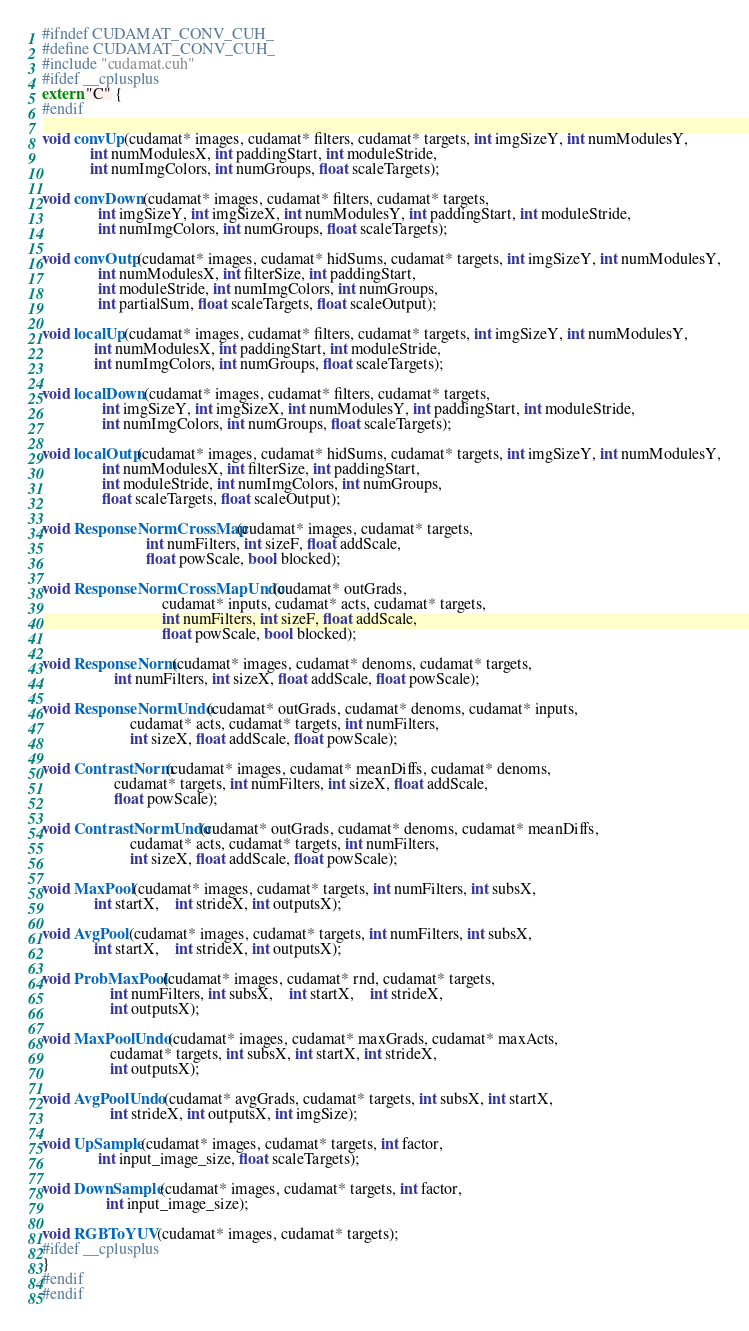Convert code to text. <code><loc_0><loc_0><loc_500><loc_500><_Cuda_>#ifndef CUDAMAT_CONV_CUH_
#define CUDAMAT_CONV_CUH_
#include "cudamat.cuh"
#ifdef __cplusplus
extern "C" {
#endif

void convUp(cudamat* images, cudamat* filters, cudamat* targets, int imgSizeY, int numModulesY,
            int numModulesX, int paddingStart, int moduleStride,
            int numImgColors, int numGroups, float scaleTargets);

void convDown(cudamat* images, cudamat* filters, cudamat* targets,
              int imgSizeY, int imgSizeX, int numModulesY, int paddingStart, int moduleStride,
              int numImgColors, int numGroups, float scaleTargets);

void convOutp(cudamat* images, cudamat* hidSums, cudamat* targets, int imgSizeY, int numModulesY,
              int numModulesX, int filterSize, int paddingStart,
              int moduleStride, int numImgColors, int numGroups,
              int partialSum, float scaleTargets, float scaleOutput);

void localUp(cudamat* images, cudamat* filters, cudamat* targets, int imgSizeY, int numModulesY,
             int numModulesX, int paddingStart, int moduleStride,
             int numImgColors, int numGroups, float scaleTargets);

void localDown(cudamat* images, cudamat* filters, cudamat* targets,
               int imgSizeY, int imgSizeX, int numModulesY, int paddingStart, int moduleStride,
               int numImgColors, int numGroups, float scaleTargets);

void localOutp(cudamat* images, cudamat* hidSums, cudamat* targets, int imgSizeY, int numModulesY,
               int numModulesX, int filterSize, int paddingStart,
               int moduleStride, int numImgColors, int numGroups,
               float scaleTargets, float scaleOutput);

void ResponseNormCrossMap(cudamat* images, cudamat* targets,
                          int numFilters, int sizeF, float addScale,
                          float powScale, bool blocked);

void ResponseNormCrossMapUndo(cudamat* outGrads,
                              cudamat* inputs, cudamat* acts, cudamat* targets,
                              int numFilters, int sizeF, float addScale,
                              float powScale, bool blocked);

void ResponseNorm(cudamat* images, cudamat* denoms, cudamat* targets,
                  int numFilters, int sizeX, float addScale, float powScale);

void ResponseNormUndo(cudamat* outGrads, cudamat* denoms, cudamat* inputs,
                      cudamat* acts, cudamat* targets, int numFilters,
                      int sizeX, float addScale, float powScale);

void ContrastNorm(cudamat* images, cudamat* meanDiffs, cudamat* denoms,
                  cudamat* targets, int numFilters, int sizeX, float addScale,
                  float powScale);

void ContrastNormUndo(cudamat* outGrads, cudamat* denoms, cudamat* meanDiffs,
                      cudamat* acts, cudamat* targets, int numFilters,
                      int sizeX, float addScale, float powScale);

void MaxPool(cudamat* images, cudamat* targets, int numFilters, int subsX,
             int startX,	int strideX, int outputsX);

void AvgPool(cudamat* images, cudamat* targets, int numFilters, int subsX,
             int startX,	int strideX, int outputsX);

void ProbMaxPool(cudamat* images, cudamat* rnd, cudamat* targets,
                 int numFilters, int subsX,	int startX,	int strideX,
                 int outputsX);

void MaxPoolUndo(cudamat* images, cudamat* maxGrads, cudamat* maxActs,
                 cudamat* targets, int subsX, int startX, int strideX,
                 int outputsX);

void AvgPoolUndo(cudamat* avgGrads, cudamat* targets, int subsX, int startX,
                 int strideX, int outputsX, int imgSize);

void UpSample(cudamat* images, cudamat* targets, int factor,
              int input_image_size, float scaleTargets);
 
void DownSample(cudamat* images, cudamat* targets, int factor,
                int input_image_size);

void RGBToYUV(cudamat* images, cudamat* targets);
#ifdef __cplusplus
}
#endif
#endif
</code> 